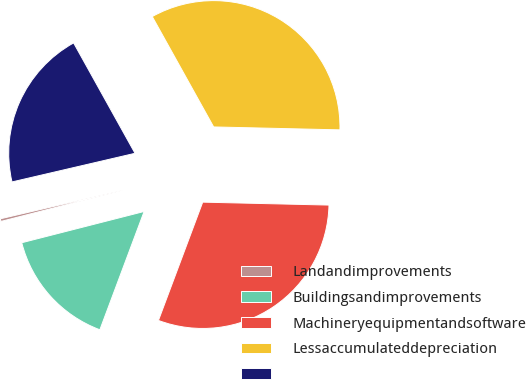Convert chart. <chart><loc_0><loc_0><loc_500><loc_500><pie_chart><fcel>Landandimprovements<fcel>Buildingsandimprovements<fcel>Machineryequipmentandsoftware<fcel>Lessaccumulateddepreciation<fcel>Unnamed: 4<nl><fcel>0.34%<fcel>15.32%<fcel>30.33%<fcel>33.45%<fcel>20.56%<nl></chart> 